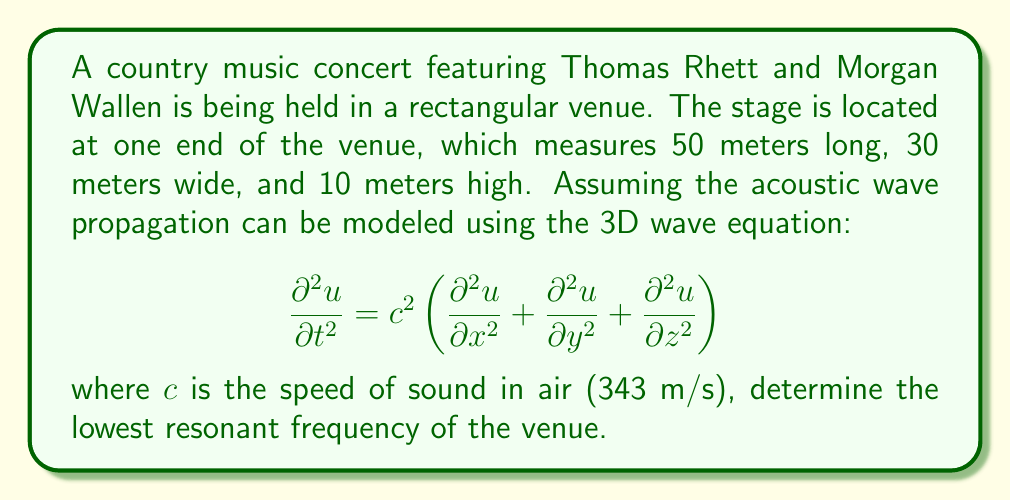Can you answer this question? To solve this problem, we need to follow these steps:

1) The general solution for the 3D wave equation in a rectangular room is:

   $$u(x,y,z,t) = \sin(\frac{n_x\pi x}{L_x}) \sin(\frac{n_y\pi y}{L_y}) \sin(\frac{n_z\pi z}{L_z}) \cos(\omega t)$$

   where $L_x$, $L_y$, and $L_z$ are the dimensions of the room, and $n_x$, $n_y$, and $n_z$ are non-negative integers.

2) The resonant frequencies are given by:

   $$f = \frac{c}{2} \sqrt{\left(\frac{n_x}{L_x}\right)^2 + \left(\frac{n_y}{L_y}\right)^2 + \left(\frac{n_z}{L_z}\right)^2}$$

3) The lowest resonant frequency occurs when $n_x = 1$, $n_y = 0$, and $n_z = 0$. Substituting these values and the given dimensions:

   $$f = \frac{343}{2} \sqrt{\left(\frac{1}{50}\right)^2 + \left(\frac{0}{30}\right)^2 + \left(\frac{0}{10}\right)^2}$$

4) Simplifying:

   $$f = \frac{343}{2} \cdot \frac{1}{50} = \frac{343}{100} = 3.43 \text{ Hz}$$

Thus, the lowest resonant frequency of the venue is 3.43 Hz.
Answer: 3.43 Hz 